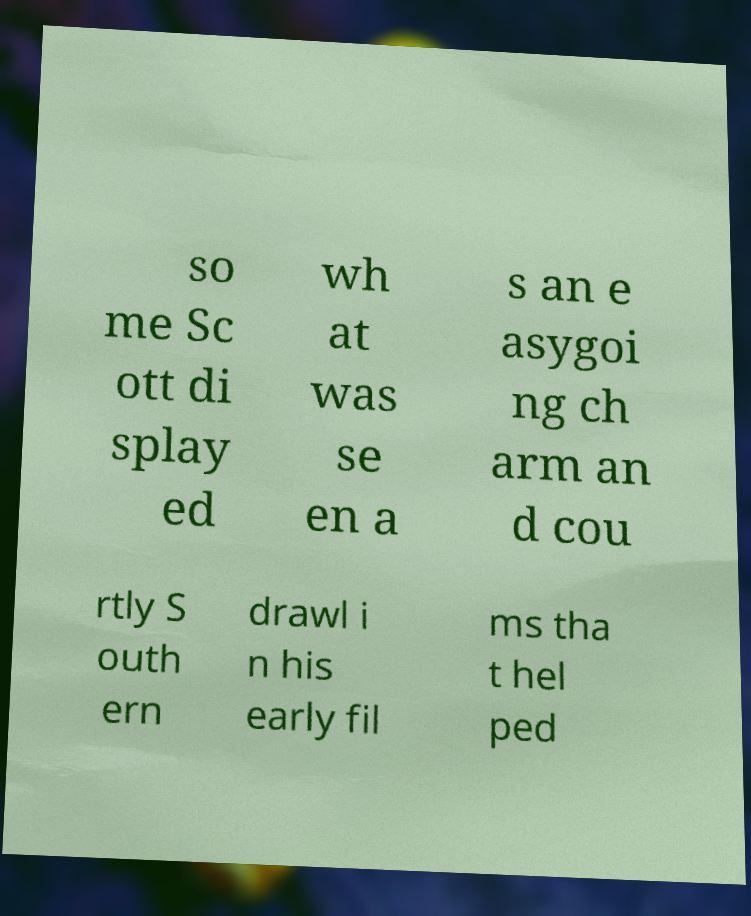I need the written content from this picture converted into text. Can you do that? so me Sc ott di splay ed wh at was se en a s an e asygoi ng ch arm an d cou rtly S outh ern drawl i n his early fil ms tha t hel ped 